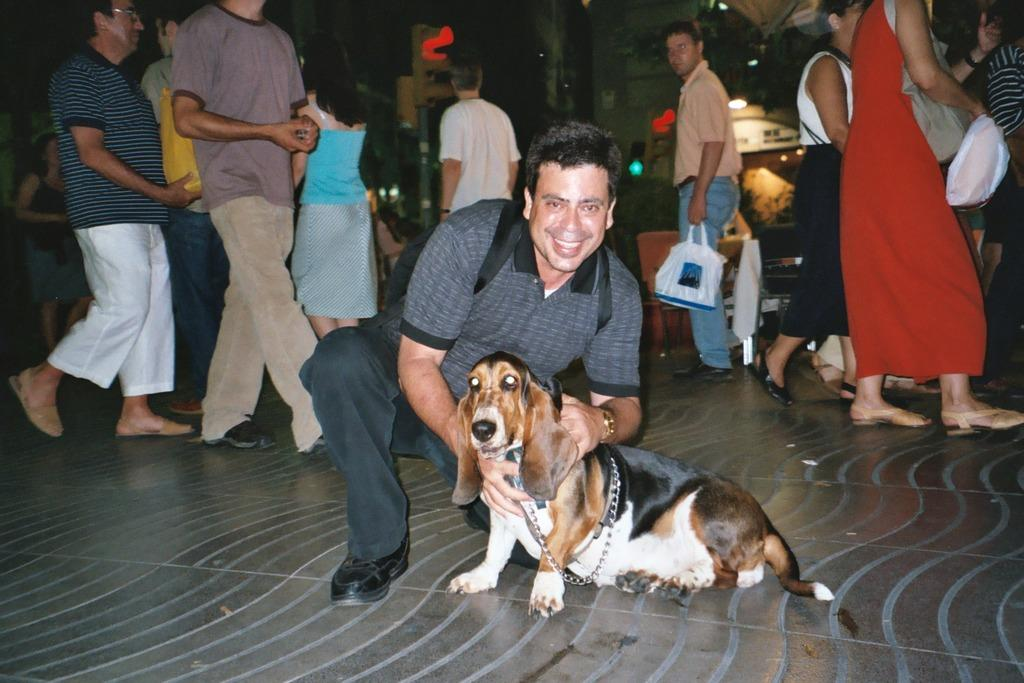What is the man in the image doing? The man is sitting on his knees and holding a dog with his hands. What is the man carrying in the image? The man is carrying a bag. What is the man's facial expression in the image? The man is smiling. What can be seen in the background of the image? There are people walking, a wall, and lights in the background of the image. What type of pickle is the man eating in the image? There is no pickle present in the image; the man is holding a dog and carrying a bag. How comfortable is the man in the image? The provided facts do not mention the man's comfort level, so we cannot determine that from the image. 